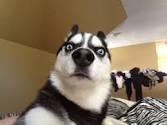What is in the picture, and what is it usually used to express? The picture shows a Siberian Husky with a surprised or shocked expression. This kind of image is often used as a meme to humorously convey feelings of surprise, shock, disbelief, or confusion. 